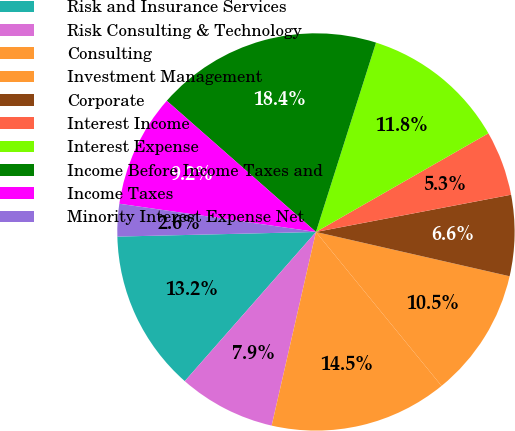Convert chart. <chart><loc_0><loc_0><loc_500><loc_500><pie_chart><fcel>Risk and Insurance Services<fcel>Risk Consulting & Technology<fcel>Consulting<fcel>Investment Management<fcel>Corporate<fcel>Interest Income<fcel>Interest Expense<fcel>Income Before Income Taxes and<fcel>Income Taxes<fcel>Minority Interest Expense Net<nl><fcel>13.15%<fcel>7.9%<fcel>14.47%<fcel>10.53%<fcel>6.58%<fcel>5.27%<fcel>11.84%<fcel>18.41%<fcel>9.21%<fcel>2.64%<nl></chart> 